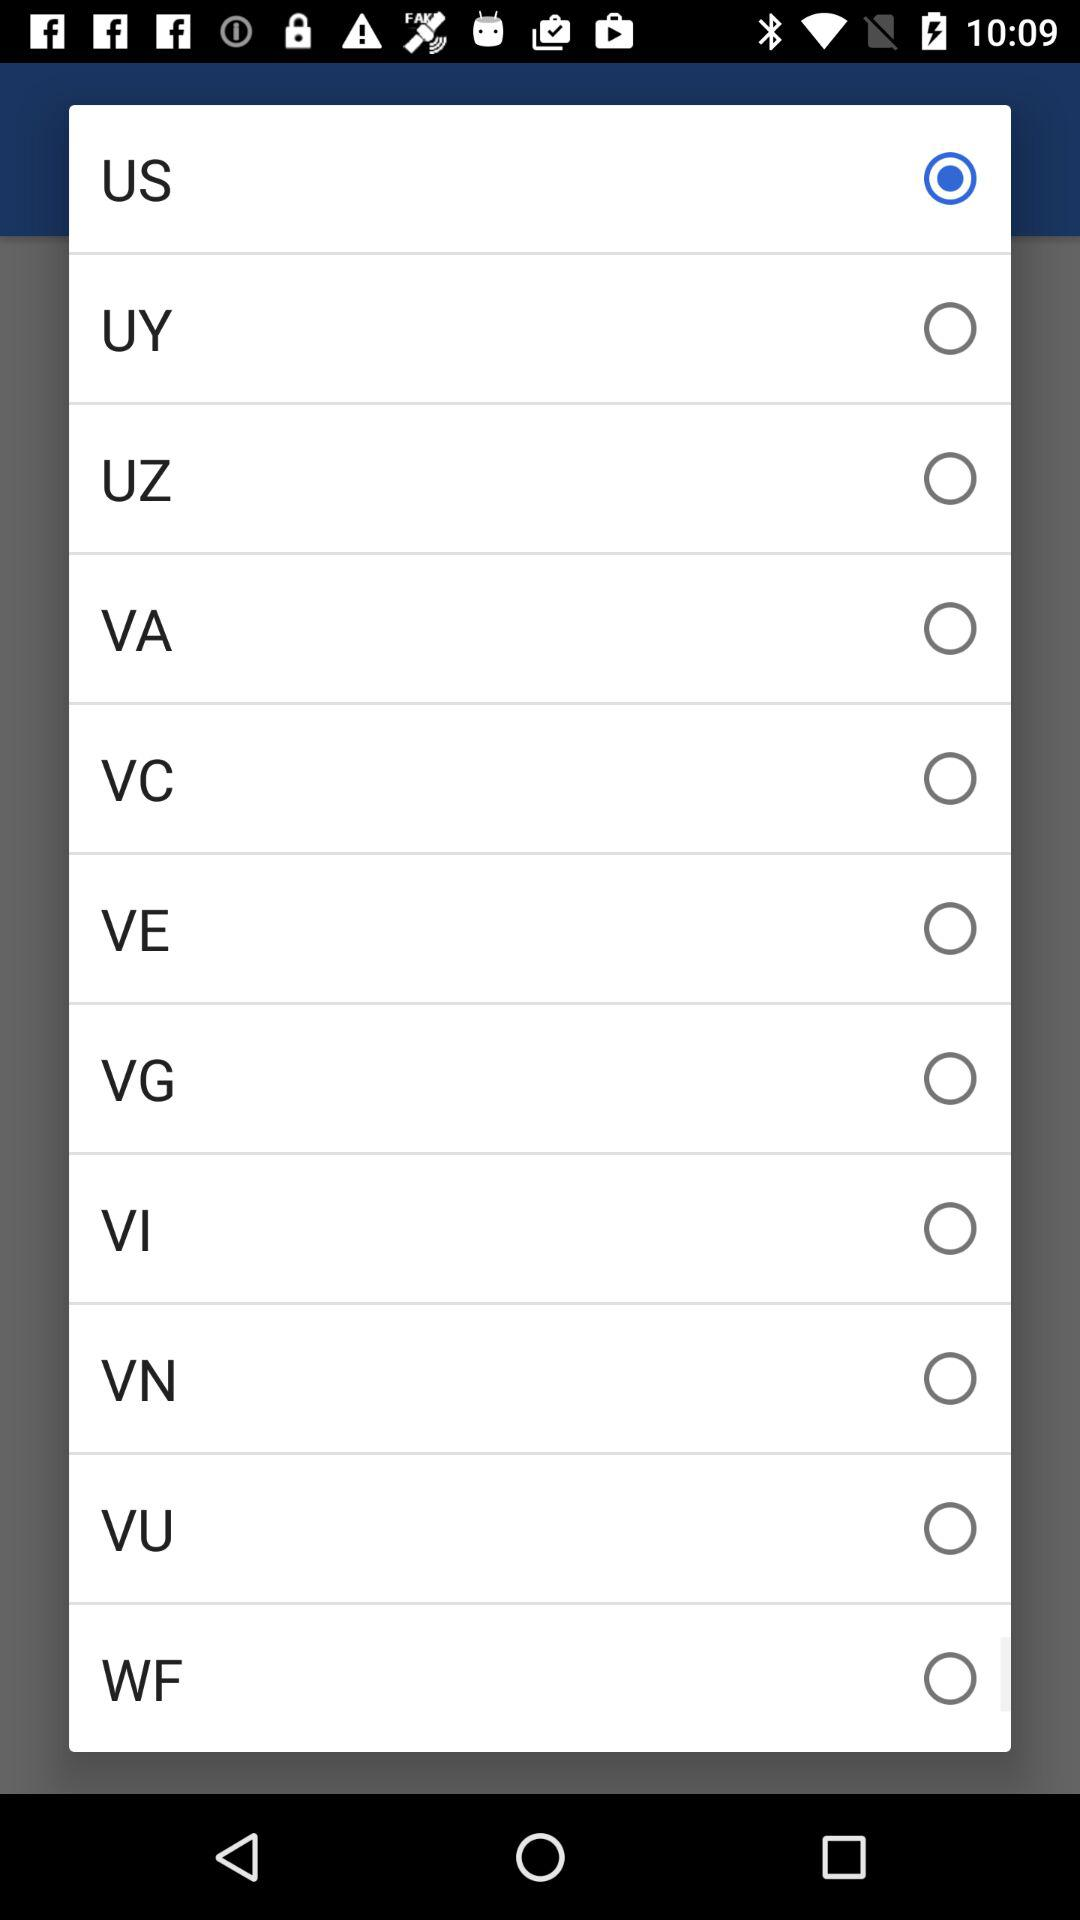Which option is selected? The selected option is "US". 